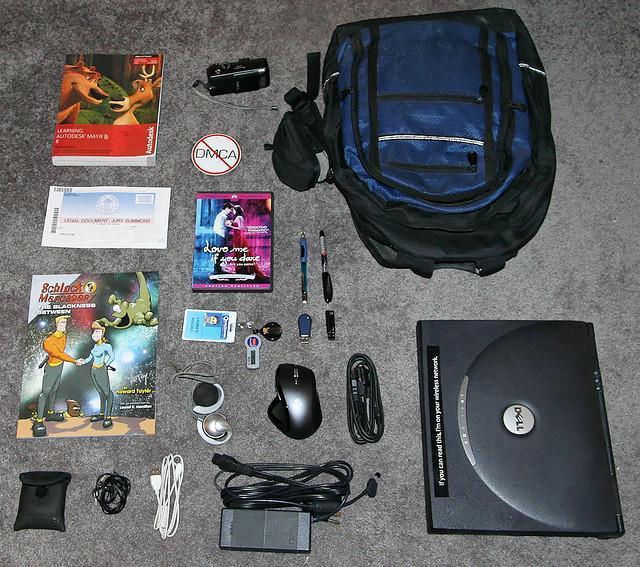How many books are there?
Give a very brief answer. 2. 